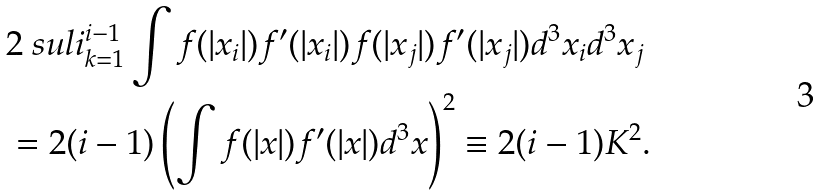<formula> <loc_0><loc_0><loc_500><loc_500>& 2 \ s u l i _ { k = 1 } ^ { i - 1 } \int f ( | x _ { i } | ) f ^ { \prime } ( | x _ { i } | ) f ( | x _ { j } | ) f ^ { \prime } ( | x _ { j } | ) d ^ { 3 } x _ { i } d ^ { 3 } x _ { j } \\ & = 2 ( i - 1 ) \left ( \int f ( | x | ) f ^ { \prime } ( | x | ) d ^ { 3 } x \right ) ^ { 2 } \equiv 2 ( i - 1 ) K ^ { 2 } .</formula> 